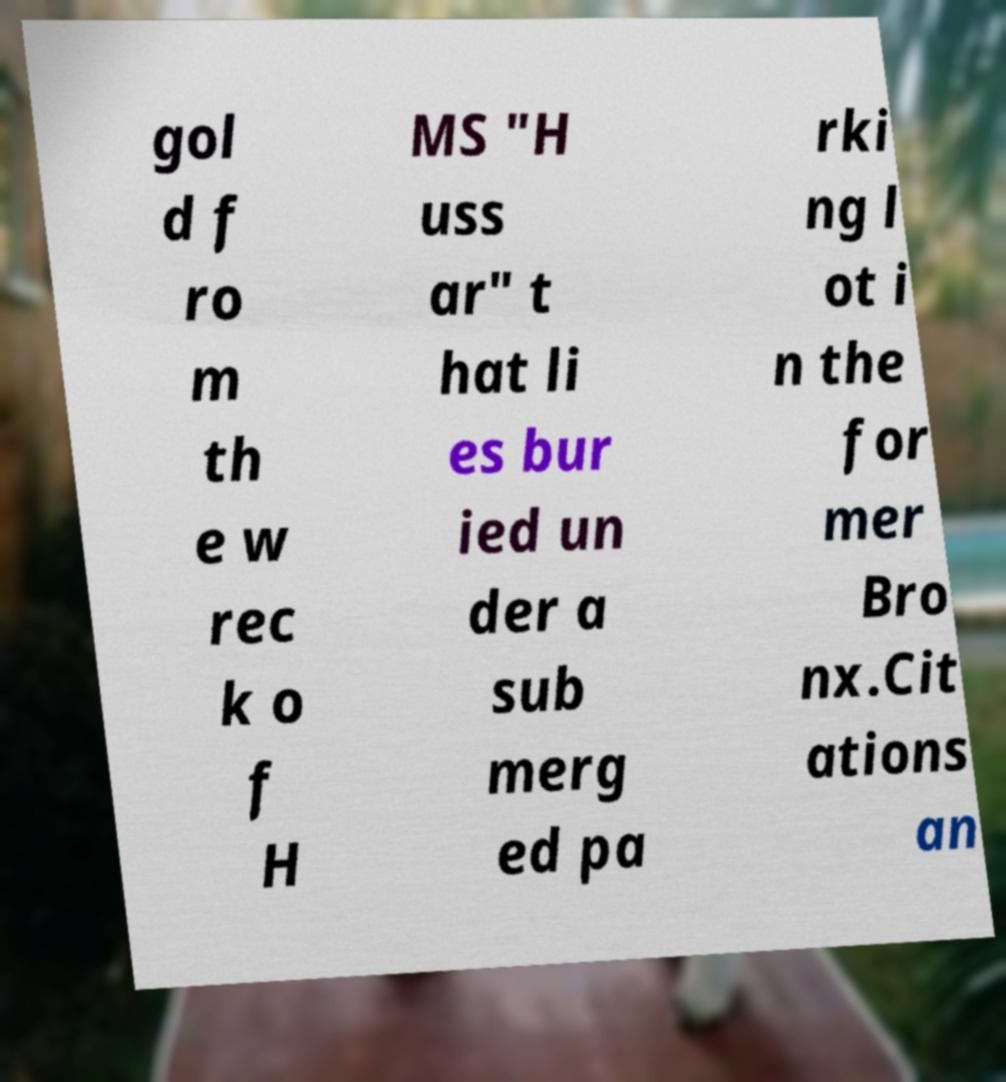Could you extract and type out the text from this image? gol d f ro m th e w rec k o f H MS "H uss ar" t hat li es bur ied un der a sub merg ed pa rki ng l ot i n the for mer Bro nx.Cit ations an 